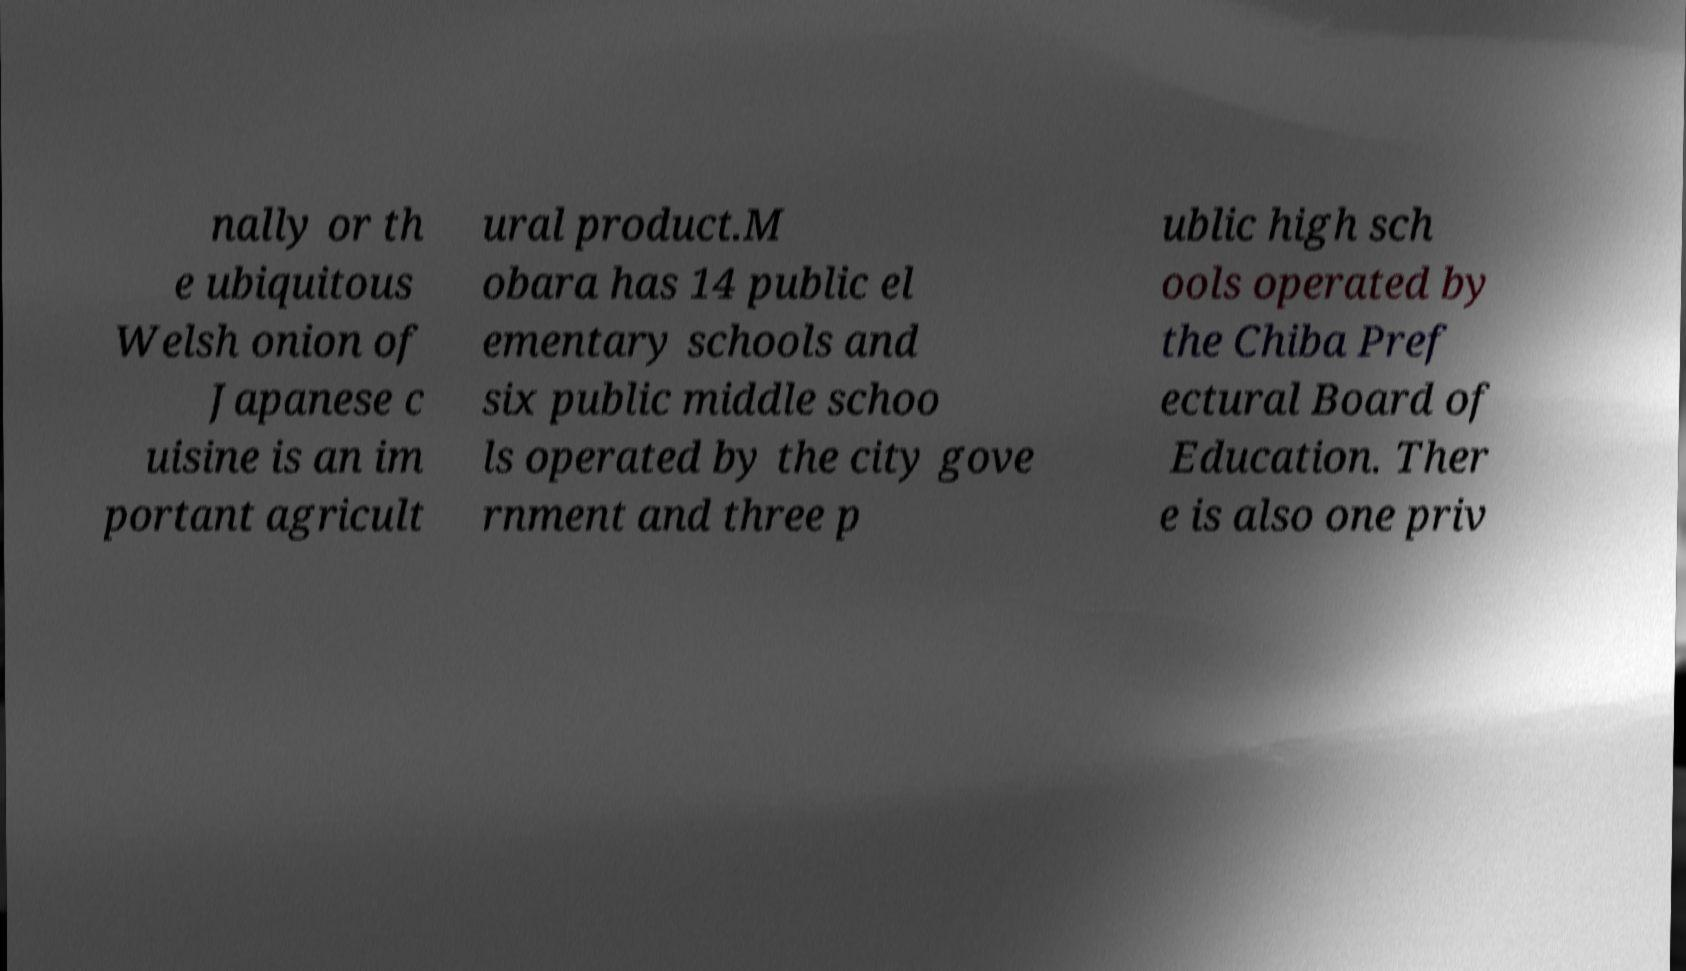Could you extract and type out the text from this image? nally or th e ubiquitous Welsh onion of Japanese c uisine is an im portant agricult ural product.M obara has 14 public el ementary schools and six public middle schoo ls operated by the city gove rnment and three p ublic high sch ools operated by the Chiba Pref ectural Board of Education. Ther e is also one priv 